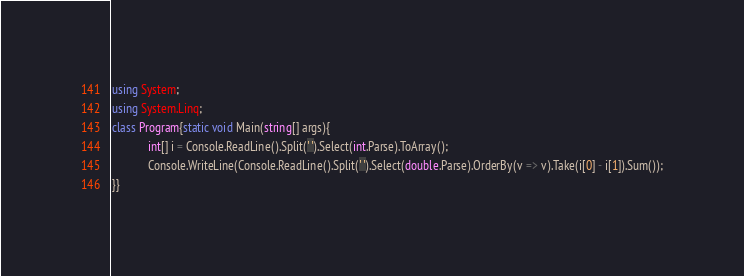<code> <loc_0><loc_0><loc_500><loc_500><_C#_>using System;
using System.Linq;
class Program{static void Main(string[] args){
            int[] i = Console.ReadLine().Split(' ').Select(int.Parse).ToArray();
            Console.WriteLine(Console.ReadLine().Split(' ').Select(double.Parse).OrderBy(v => v).Take(i[0] - i[1]).Sum());
}}</code> 